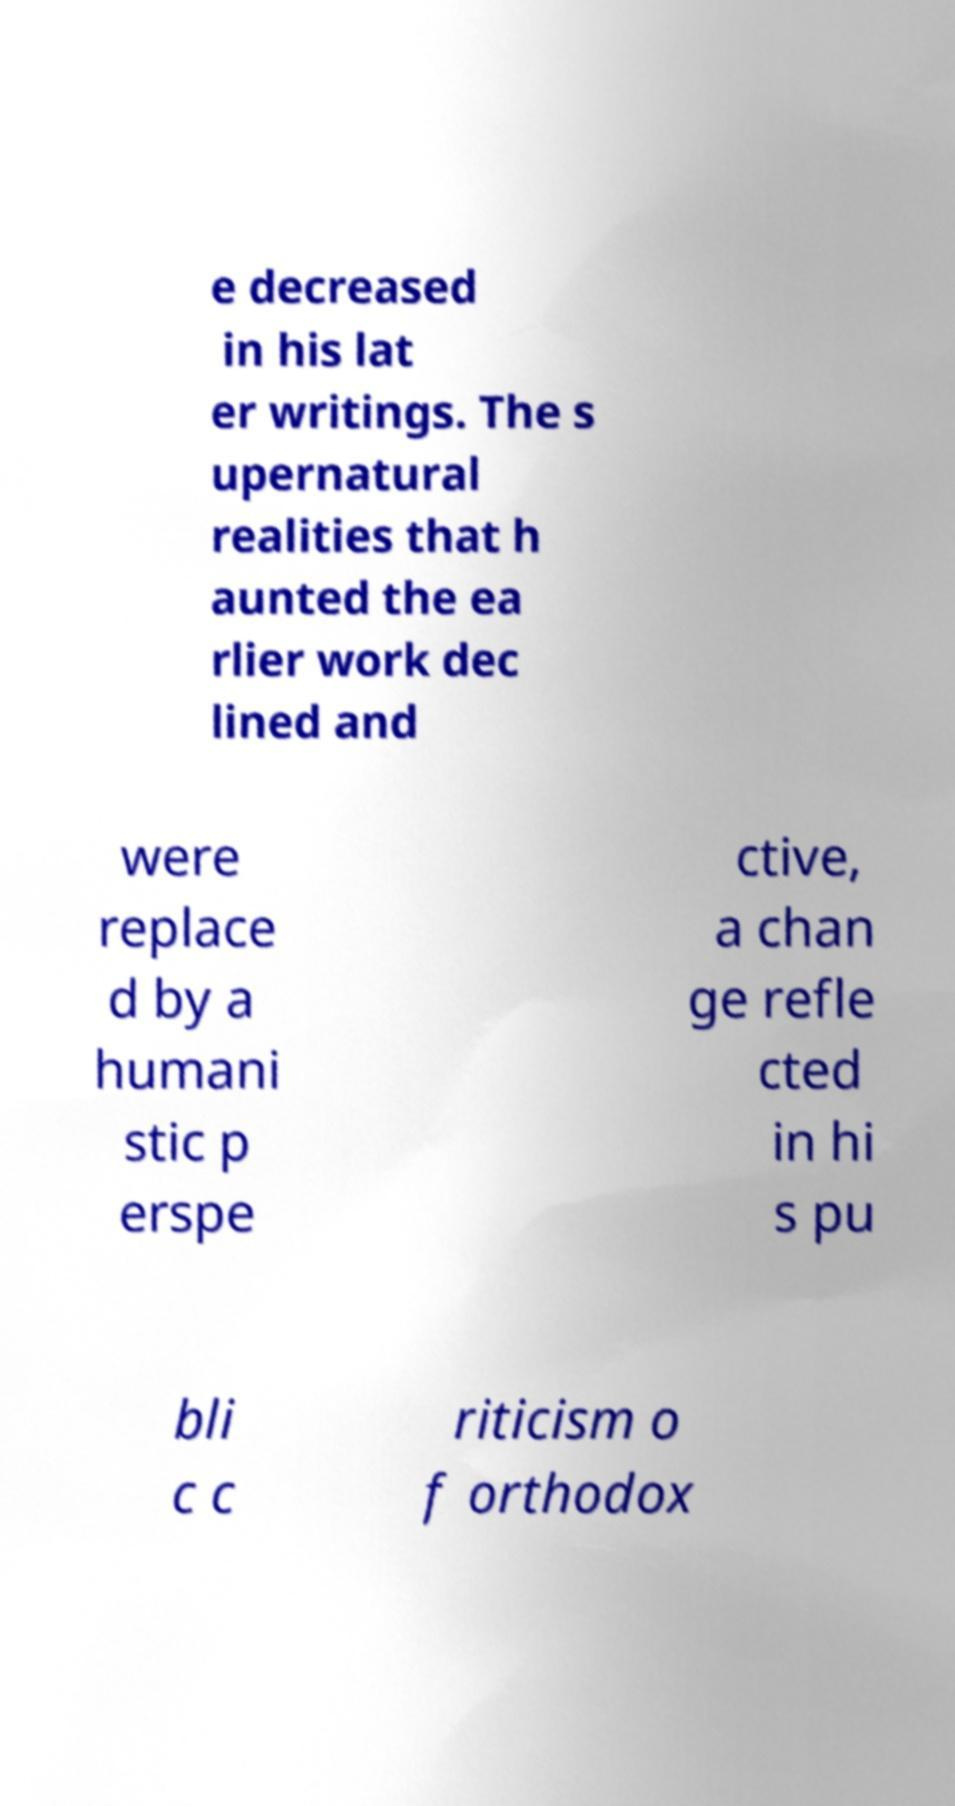What messages or text are displayed in this image? I need them in a readable, typed format. e decreased in his lat er writings. The s upernatural realities that h aunted the ea rlier work dec lined and were replace d by a humani stic p erspe ctive, a chan ge refle cted in hi s pu bli c c riticism o f orthodox 